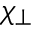Convert formula to latex. <formula><loc_0><loc_0><loc_500><loc_500>\chi _ { \perp }</formula> 